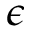Convert formula to latex. <formula><loc_0><loc_0><loc_500><loc_500>\epsilon</formula> 